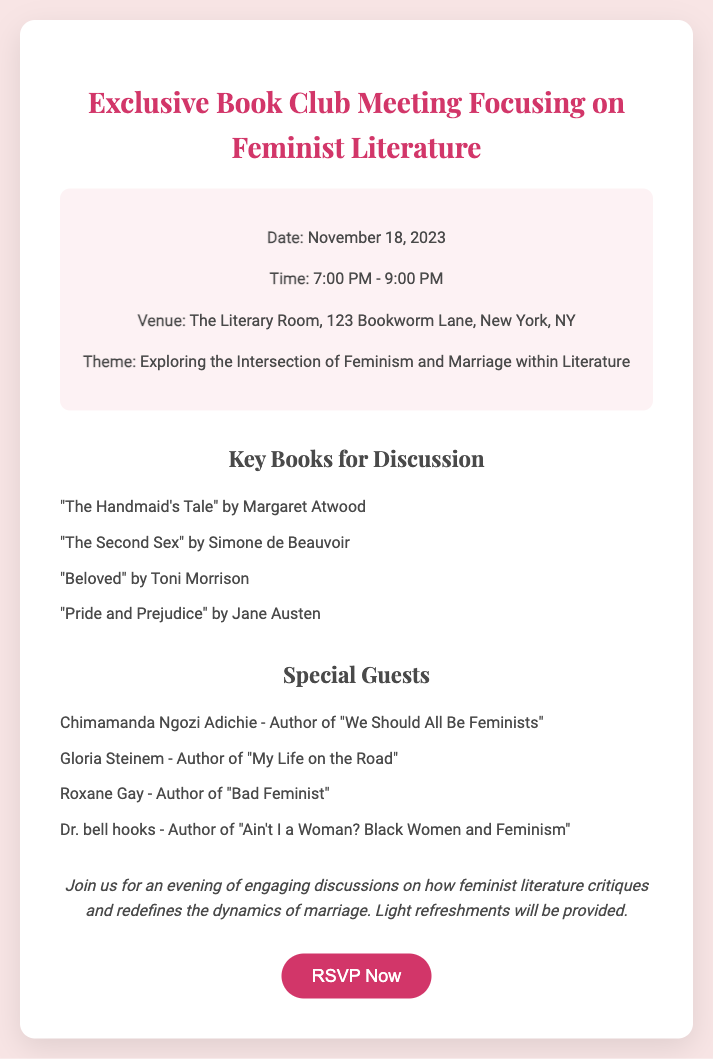What is the date of the meeting? The date of the meeting can be found in the event details section of the document, which states it is November 18, 2023.
Answer: November 18, 2023 What is the location of the venue? The venue information is located in the event details section, which specifies "The Literary Room, 123 Bookworm Lane, New York, NY."
Answer: The Literary Room, 123 Bookworm Lane, New York, NY Who is a special guest attending the meeting? The special guests can be found in the guest list section, where multiple names are listed. For example, "Chimamanda Ngozi Adichie" is one of them.
Answer: Chimamanda Ngozi Adichie How many key books are listed for discussion? The number of key books is determined by counting the items in the book list section, which includes four books.
Answer: Four What is the theme of the discussion? The theme is mentioned in the event details, stating "Exploring the Intersection of Feminism and Marriage within Literature."
Answer: Exploring the Intersection of Feminism and Marriage within Literature What time does the meeting start? The start time is included in the event details section, which indicates that the meeting begins at 7:00 PM.
Answer: 7:00 PM What type of refreshments will be provided? The additional info section mentions "Light refreshments" will be provided without specifying any types.
Answer: Light refreshments What book by Toni Morrison is featured in the discussion? The book by Toni Morrison mentioned in the key books for discussion is listed in the book list section.
Answer: "Beloved" 